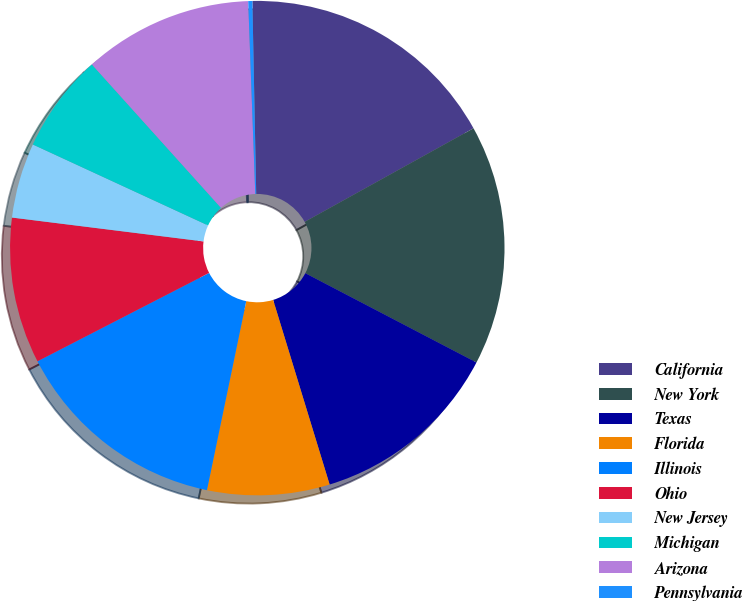Convert chart to OTSL. <chart><loc_0><loc_0><loc_500><loc_500><pie_chart><fcel>California<fcel>New York<fcel>Texas<fcel>Florida<fcel>Illinois<fcel>Ohio<fcel>New Jersey<fcel>Michigan<fcel>Arizona<fcel>Pennsylvania<nl><fcel>17.26%<fcel>15.71%<fcel>12.62%<fcel>7.99%<fcel>14.17%<fcel>9.54%<fcel>4.91%<fcel>6.45%<fcel>11.08%<fcel>0.27%<nl></chart> 